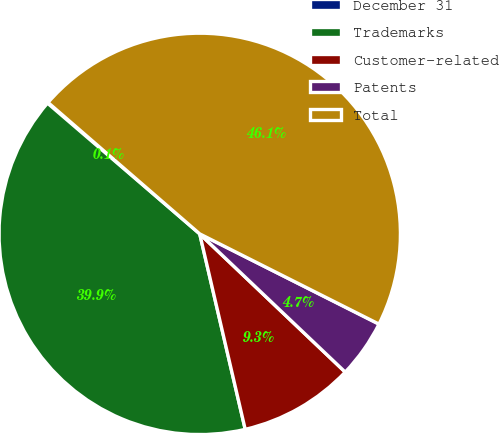<chart> <loc_0><loc_0><loc_500><loc_500><pie_chart><fcel>December 31<fcel>Trademarks<fcel>Customer-related<fcel>Patents<fcel>Total<nl><fcel>0.07%<fcel>39.93%<fcel>9.27%<fcel>4.67%<fcel>46.06%<nl></chart> 